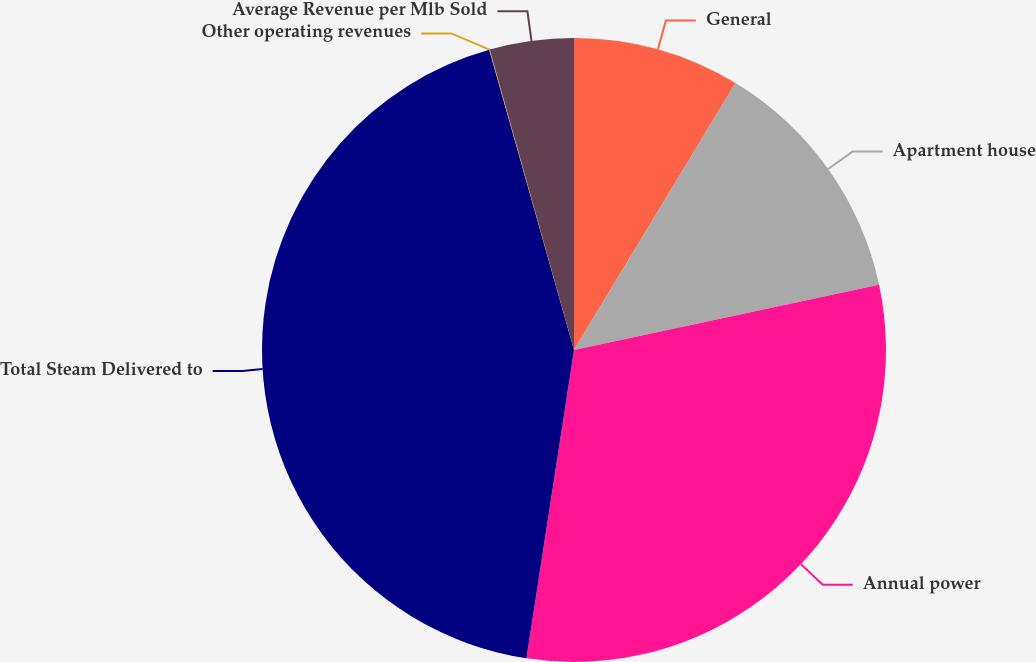Convert chart. <chart><loc_0><loc_0><loc_500><loc_500><pie_chart><fcel>General<fcel>Apartment house<fcel>Annual power<fcel>Total Steam Delivered to<fcel>Other operating revenues<fcel>Average Revenue per Mlb Sold<nl><fcel>8.66%<fcel>12.98%<fcel>30.79%<fcel>43.18%<fcel>0.03%<fcel>4.35%<nl></chart> 